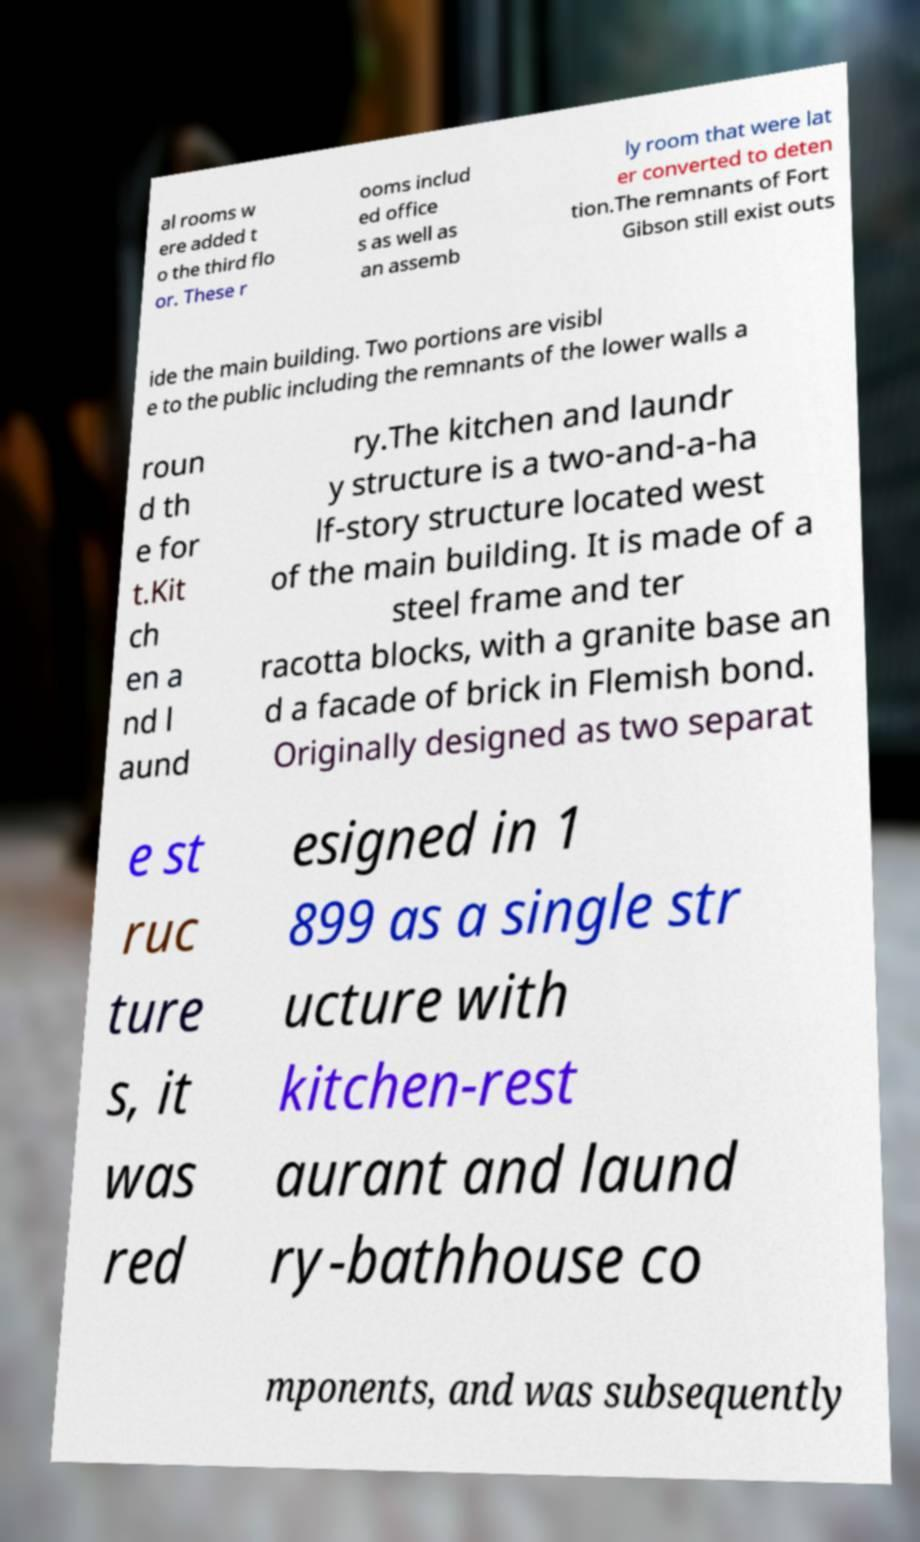Could you assist in decoding the text presented in this image and type it out clearly? al rooms w ere added t o the third flo or. These r ooms includ ed office s as well as an assemb ly room that were lat er converted to deten tion.The remnants of Fort Gibson still exist outs ide the main building. Two portions are visibl e to the public including the remnants of the lower walls a roun d th e for t.Kit ch en a nd l aund ry.The kitchen and laundr y structure is a two-and-a-ha lf-story structure located west of the main building. It is made of a steel frame and ter racotta blocks, with a granite base an d a facade of brick in Flemish bond. Originally designed as two separat e st ruc ture s, it was red esigned in 1 899 as a single str ucture with kitchen-rest aurant and laund ry-bathhouse co mponents, and was subsequently 